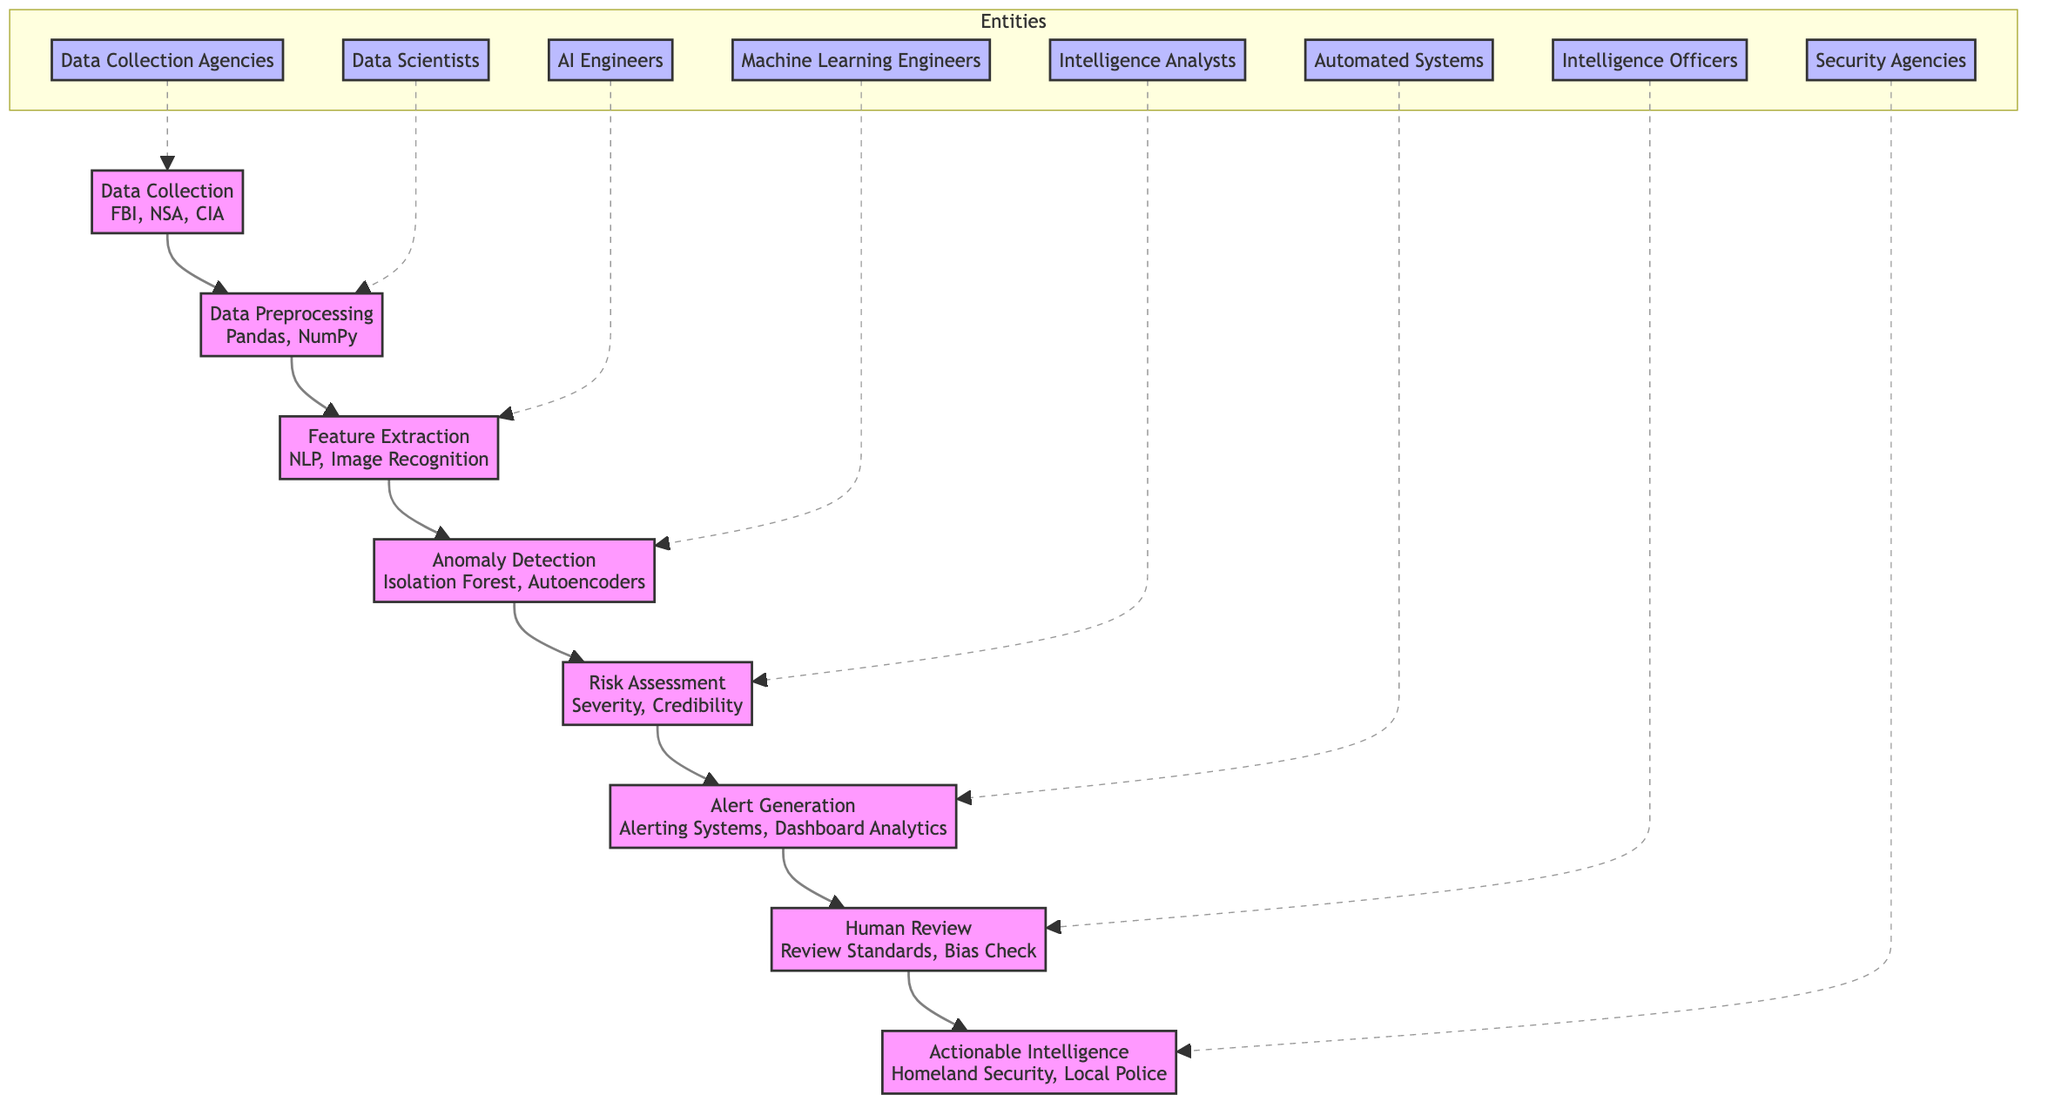What is the first step in the workflow? The first step in the workflow, depicted in the diagram, is "Data Collection". This can be observed as the starting node that gathers data from various sources.
Answer: Data Collection Who is responsible for Feature Extraction? The person responsible for Feature Extraction is "AI Engineers", as indicated by the connection from the "Feature Extraction" node to the "AI Engineers" in the entities section of the diagram.
Answer: AI Engineers How many distinct steps are there in the workflow? The diagram includes eight distinct steps in the workflow, starting from "Data Collection" to "Actionable Intelligence". Each step is represented by a single node.
Answer: Eight What tools are used in Data Preprocessing? The tools used in Data Preprocessing, as specified in the node description, are "Pandas" and "NumPy". These tools are mentioned directly under the Data Preprocessing node.
Answer: Pandas, NumPy What follows Anomaly Detection in the workflow? The step that follows Anomaly Detection is "Risk Assessment" as shown in the flow of the diagram that connects these two nodes sequentially.
Answer: Risk Assessment What criteria are evaluated in the Risk Assessment step? In the Risk Assessment step, the criteria evaluated are "Severity" and "Credibility", which are part of the description for that specific node in the diagram.
Answer: Severity, Credibility Who generates alerts for human review? The entity responsible for generating alerts for human review is "Automated Systems", as noted in the connection from the Alert Generation node to the respective entity in the diagram.
Answer: Automated Systems What is the final output of the process? The final output of the process as laid out in the diagram is "Actionable Intelligence". This node represents the end of the workflow where verified threat information is disseminated.
Answer: Actionable Intelligence How do the entities relate to the workflows? Entities like "Data Collection Agencies," "Data Scientists," and others are connected to specific workflow steps, indicating that they are responsible for those respective phases in the process. Each entity has a dashed line linking it to a node, showing their relationship to the flowchart.
Answer: They are responsible for specific workflow phases 